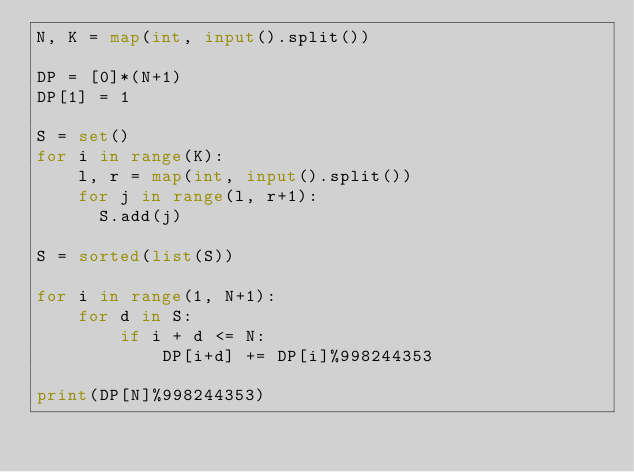<code> <loc_0><loc_0><loc_500><loc_500><_Python_>N, K = map(int, input().split())

DP = [0]*(N+1)
DP[1] = 1

S = set()
for i in range(K):
    l, r = map(int, input().split())
    for j in range(l, r+1):
      S.add(j)

S = sorted(list(S))

for i in range(1, N+1):
    for d in S:
        if i + d <= N:
            DP[i+d] += DP[i]%998244353

print(DP[N]%998244353)</code> 